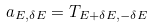<formula> <loc_0><loc_0><loc_500><loc_500>a _ { E , \delta E } = T _ { E + \delta E , - \delta E }</formula> 